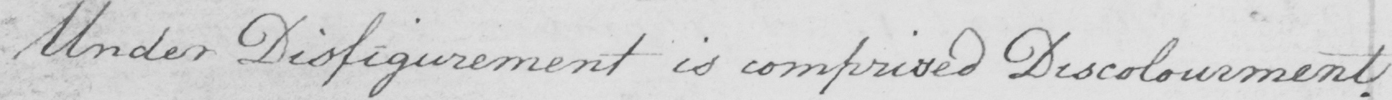Please transcribe the handwritten text in this image. Under Disfigurement is comprised Discolourment. 